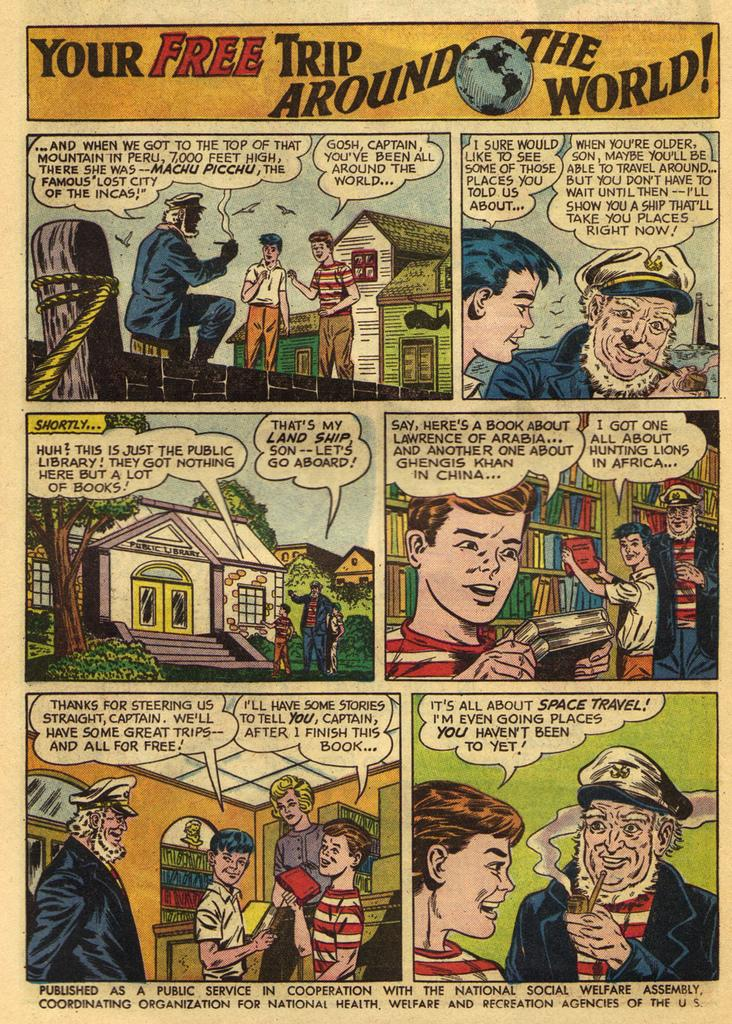<image>
Render a clear and concise summary of the photo. A comic strip titled Your Free Trip Around the World 